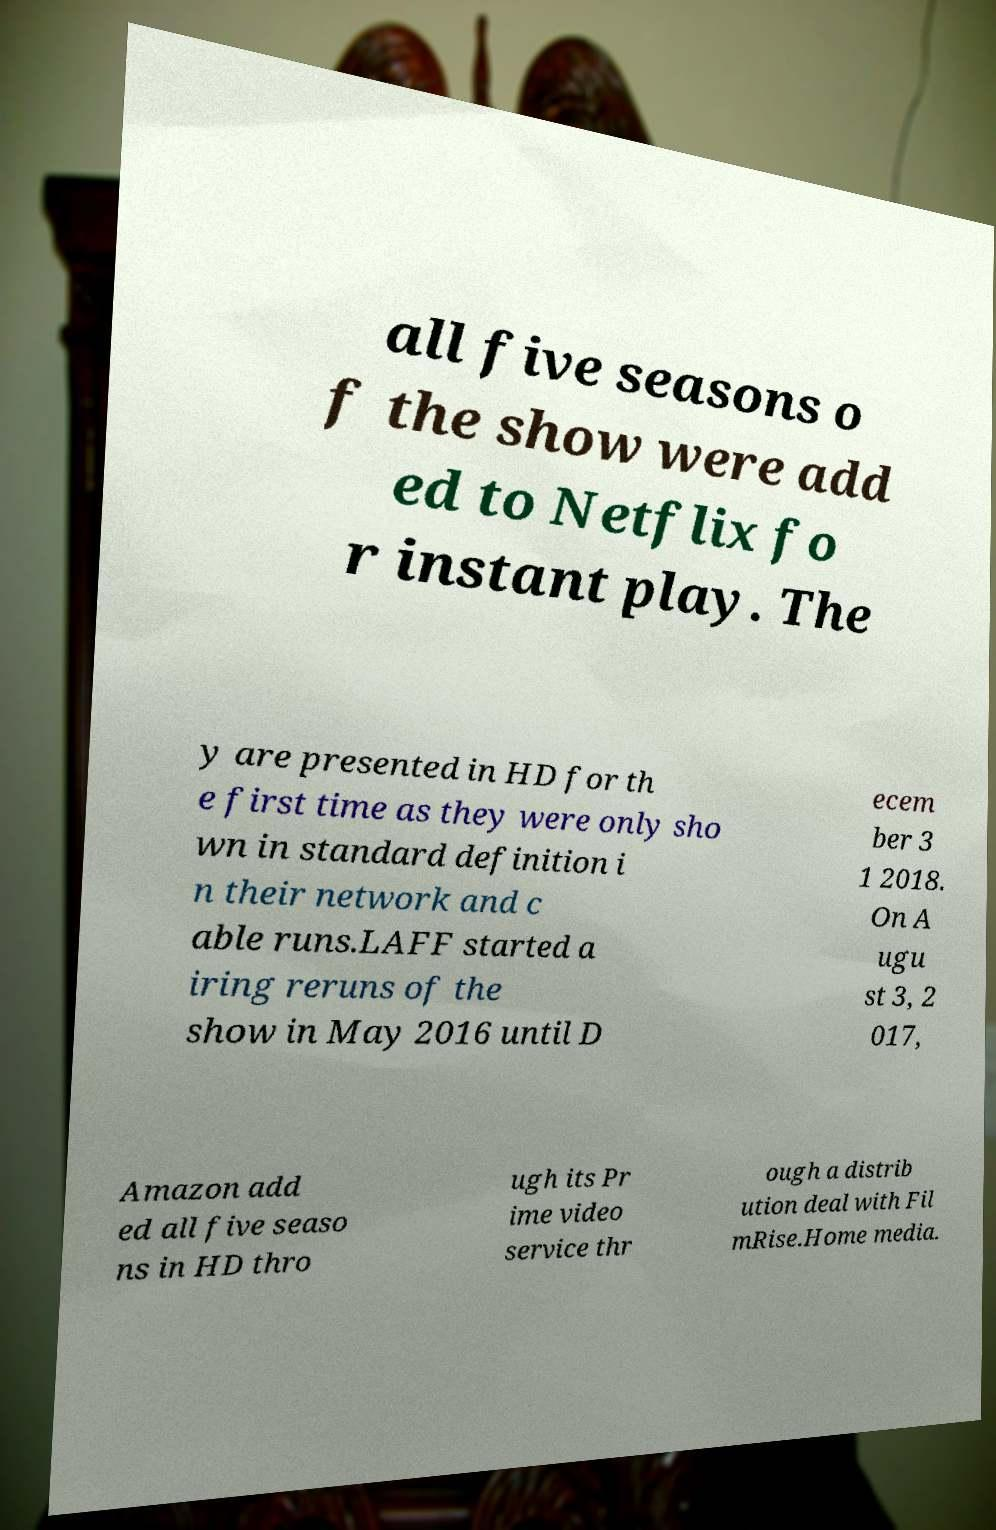Could you extract and type out the text from this image? all five seasons o f the show were add ed to Netflix fo r instant play. The y are presented in HD for th e first time as they were only sho wn in standard definition i n their network and c able runs.LAFF started a iring reruns of the show in May 2016 until D ecem ber 3 1 2018. On A ugu st 3, 2 017, Amazon add ed all five seaso ns in HD thro ugh its Pr ime video service thr ough a distrib ution deal with Fil mRise.Home media. 